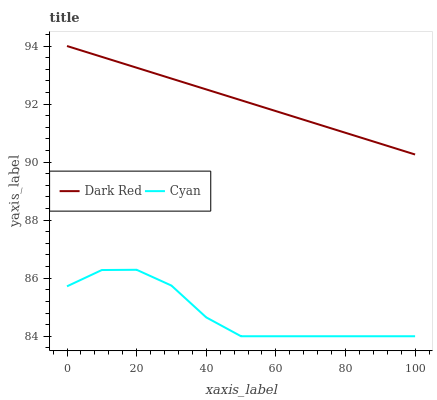Does Cyan have the minimum area under the curve?
Answer yes or no. Yes. Does Dark Red have the maximum area under the curve?
Answer yes or no. Yes. Does Cyan have the maximum area under the curve?
Answer yes or no. No. Is Dark Red the smoothest?
Answer yes or no. Yes. Is Cyan the roughest?
Answer yes or no. Yes. Is Cyan the smoothest?
Answer yes or no. No. Does Cyan have the lowest value?
Answer yes or no. Yes. Does Dark Red have the highest value?
Answer yes or no. Yes. Does Cyan have the highest value?
Answer yes or no. No. Is Cyan less than Dark Red?
Answer yes or no. Yes. Is Dark Red greater than Cyan?
Answer yes or no. Yes. Does Cyan intersect Dark Red?
Answer yes or no. No. 